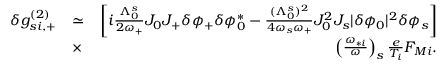<formula> <loc_0><loc_0><loc_500><loc_500>\begin{array} { r l r } { \delta g _ { s i , + } ^ { ( 2 ) } } & { \simeq } & { \left [ i \frac { \Lambda _ { 0 } ^ { s } } { 2 \omega _ { + } } J _ { 0 } J _ { + } \delta \phi _ { + } \delta \phi _ { 0 } ^ { * } - \frac { ( \Lambda _ { 0 } ^ { s } ) ^ { 2 } } { 4 \omega _ { s } \omega _ { + } } J _ { 0 } ^ { 2 } J _ { s } | \delta \phi _ { 0 } | ^ { 2 } \delta \phi _ { s } \right ] } \\ & { \times } & { \left ( \frac { \omega _ { * i } } { \omega } \right ) _ { s } \frac { e } { T _ { i } } F _ { M i } . } \end{array}</formula> 